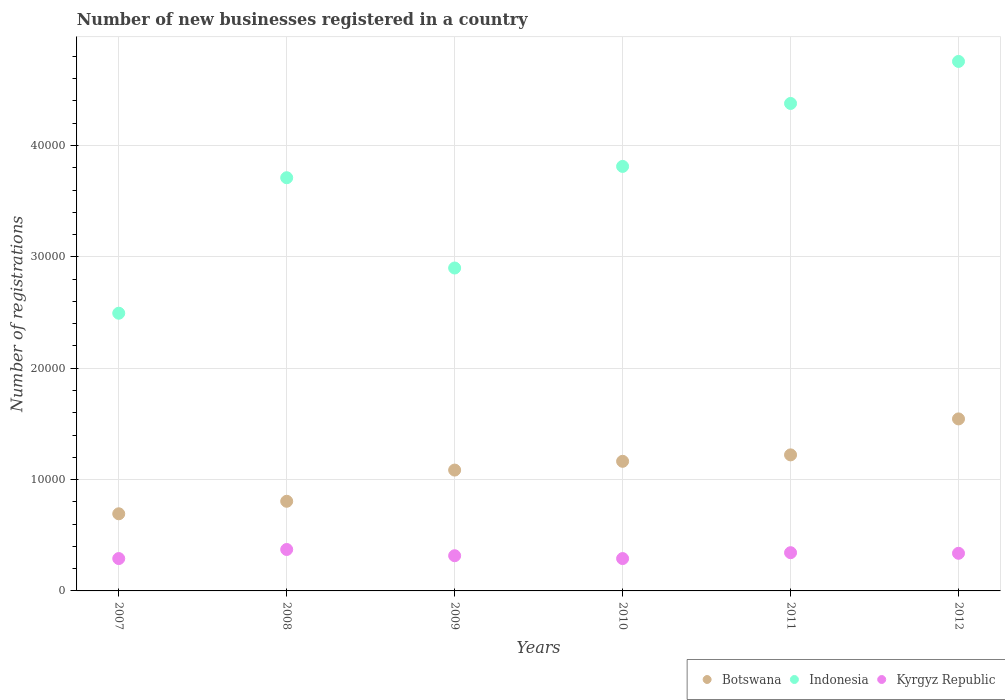What is the number of new businesses registered in Kyrgyz Republic in 2009?
Keep it short and to the point. 3161. Across all years, what is the maximum number of new businesses registered in Kyrgyz Republic?
Ensure brevity in your answer.  3721. Across all years, what is the minimum number of new businesses registered in Kyrgyz Republic?
Your response must be concise. 2905. In which year was the number of new businesses registered in Botswana minimum?
Keep it short and to the point. 2007. What is the total number of new businesses registered in Botswana in the graph?
Make the answer very short. 6.51e+04. What is the difference between the number of new businesses registered in Kyrgyz Republic in 2009 and that in 2012?
Provide a succinct answer. -218. What is the difference between the number of new businesses registered in Indonesia in 2012 and the number of new businesses registered in Botswana in 2010?
Keep it short and to the point. 3.59e+04. What is the average number of new businesses registered in Indonesia per year?
Offer a very short reply. 3.67e+04. In the year 2008, what is the difference between the number of new businesses registered in Kyrgyz Republic and number of new businesses registered in Botswana?
Your answer should be very brief. -4329. In how many years, is the number of new businesses registered in Botswana greater than 28000?
Your answer should be compact. 0. What is the ratio of the number of new businesses registered in Kyrgyz Republic in 2007 to that in 2009?
Provide a succinct answer. 0.92. Is the number of new businesses registered in Indonesia in 2010 less than that in 2012?
Ensure brevity in your answer.  Yes. Is the difference between the number of new businesses registered in Kyrgyz Republic in 2009 and 2012 greater than the difference between the number of new businesses registered in Botswana in 2009 and 2012?
Keep it short and to the point. Yes. What is the difference between the highest and the second highest number of new businesses registered in Kyrgyz Republic?
Ensure brevity in your answer.  288. What is the difference between the highest and the lowest number of new businesses registered in Botswana?
Your response must be concise. 8520. Is the sum of the number of new businesses registered in Indonesia in 2007 and 2009 greater than the maximum number of new businesses registered in Kyrgyz Republic across all years?
Your answer should be compact. Yes. Does the number of new businesses registered in Kyrgyz Republic monotonically increase over the years?
Give a very brief answer. No. What is the difference between two consecutive major ticks on the Y-axis?
Your answer should be very brief. 10000. Are the values on the major ticks of Y-axis written in scientific E-notation?
Offer a terse response. No. Does the graph contain any zero values?
Provide a short and direct response. No. Where does the legend appear in the graph?
Offer a terse response. Bottom right. What is the title of the graph?
Ensure brevity in your answer.  Number of new businesses registered in a country. What is the label or title of the Y-axis?
Provide a short and direct response. Number of registrations. What is the Number of registrations in Botswana in 2007?
Provide a short and direct response. 6927. What is the Number of registrations of Indonesia in 2007?
Your answer should be compact. 2.49e+04. What is the Number of registrations of Kyrgyz Republic in 2007?
Your response must be concise. 2906. What is the Number of registrations of Botswana in 2008?
Your answer should be very brief. 8050. What is the Number of registrations of Indonesia in 2008?
Make the answer very short. 3.71e+04. What is the Number of registrations of Kyrgyz Republic in 2008?
Your response must be concise. 3721. What is the Number of registrations of Botswana in 2009?
Ensure brevity in your answer.  1.09e+04. What is the Number of registrations of Indonesia in 2009?
Your response must be concise. 2.90e+04. What is the Number of registrations in Kyrgyz Republic in 2009?
Provide a short and direct response. 3161. What is the Number of registrations in Botswana in 2010?
Your response must be concise. 1.16e+04. What is the Number of registrations of Indonesia in 2010?
Your answer should be compact. 3.81e+04. What is the Number of registrations of Kyrgyz Republic in 2010?
Your answer should be compact. 2905. What is the Number of registrations of Botswana in 2011?
Ensure brevity in your answer.  1.22e+04. What is the Number of registrations in Indonesia in 2011?
Your answer should be very brief. 4.38e+04. What is the Number of registrations of Kyrgyz Republic in 2011?
Offer a terse response. 3433. What is the Number of registrations of Botswana in 2012?
Your response must be concise. 1.54e+04. What is the Number of registrations in Indonesia in 2012?
Offer a terse response. 4.75e+04. What is the Number of registrations of Kyrgyz Republic in 2012?
Provide a succinct answer. 3379. Across all years, what is the maximum Number of registrations in Botswana?
Your answer should be compact. 1.54e+04. Across all years, what is the maximum Number of registrations of Indonesia?
Offer a terse response. 4.75e+04. Across all years, what is the maximum Number of registrations in Kyrgyz Republic?
Give a very brief answer. 3721. Across all years, what is the minimum Number of registrations in Botswana?
Make the answer very short. 6927. Across all years, what is the minimum Number of registrations of Indonesia?
Provide a short and direct response. 2.49e+04. Across all years, what is the minimum Number of registrations of Kyrgyz Republic?
Ensure brevity in your answer.  2905. What is the total Number of registrations in Botswana in the graph?
Provide a short and direct response. 6.51e+04. What is the total Number of registrations in Indonesia in the graph?
Your answer should be compact. 2.20e+05. What is the total Number of registrations of Kyrgyz Republic in the graph?
Provide a short and direct response. 1.95e+04. What is the difference between the Number of registrations of Botswana in 2007 and that in 2008?
Give a very brief answer. -1123. What is the difference between the Number of registrations in Indonesia in 2007 and that in 2008?
Keep it short and to the point. -1.22e+04. What is the difference between the Number of registrations in Kyrgyz Republic in 2007 and that in 2008?
Offer a very short reply. -815. What is the difference between the Number of registrations in Botswana in 2007 and that in 2009?
Keep it short and to the point. -3925. What is the difference between the Number of registrations of Indonesia in 2007 and that in 2009?
Offer a terse response. -4060. What is the difference between the Number of registrations in Kyrgyz Republic in 2007 and that in 2009?
Ensure brevity in your answer.  -255. What is the difference between the Number of registrations in Botswana in 2007 and that in 2010?
Provide a succinct answer. -4712. What is the difference between the Number of registrations in Indonesia in 2007 and that in 2010?
Give a very brief answer. -1.32e+04. What is the difference between the Number of registrations of Kyrgyz Republic in 2007 and that in 2010?
Your answer should be very brief. 1. What is the difference between the Number of registrations in Botswana in 2007 and that in 2011?
Offer a very short reply. -5290. What is the difference between the Number of registrations in Indonesia in 2007 and that in 2011?
Keep it short and to the point. -1.88e+04. What is the difference between the Number of registrations in Kyrgyz Republic in 2007 and that in 2011?
Your answer should be very brief. -527. What is the difference between the Number of registrations in Botswana in 2007 and that in 2012?
Offer a very short reply. -8520. What is the difference between the Number of registrations in Indonesia in 2007 and that in 2012?
Offer a very short reply. -2.26e+04. What is the difference between the Number of registrations of Kyrgyz Republic in 2007 and that in 2012?
Your answer should be compact. -473. What is the difference between the Number of registrations in Botswana in 2008 and that in 2009?
Keep it short and to the point. -2802. What is the difference between the Number of registrations in Indonesia in 2008 and that in 2009?
Ensure brevity in your answer.  8108. What is the difference between the Number of registrations in Kyrgyz Republic in 2008 and that in 2009?
Provide a short and direct response. 560. What is the difference between the Number of registrations in Botswana in 2008 and that in 2010?
Give a very brief answer. -3589. What is the difference between the Number of registrations of Indonesia in 2008 and that in 2010?
Offer a terse response. -1016. What is the difference between the Number of registrations in Kyrgyz Republic in 2008 and that in 2010?
Your answer should be compact. 816. What is the difference between the Number of registrations of Botswana in 2008 and that in 2011?
Give a very brief answer. -4167. What is the difference between the Number of registrations of Indonesia in 2008 and that in 2011?
Your answer should be very brief. -6669. What is the difference between the Number of registrations in Kyrgyz Republic in 2008 and that in 2011?
Provide a short and direct response. 288. What is the difference between the Number of registrations of Botswana in 2008 and that in 2012?
Ensure brevity in your answer.  -7397. What is the difference between the Number of registrations of Indonesia in 2008 and that in 2012?
Offer a terse response. -1.04e+04. What is the difference between the Number of registrations in Kyrgyz Republic in 2008 and that in 2012?
Offer a terse response. 342. What is the difference between the Number of registrations of Botswana in 2009 and that in 2010?
Make the answer very short. -787. What is the difference between the Number of registrations of Indonesia in 2009 and that in 2010?
Your response must be concise. -9124. What is the difference between the Number of registrations of Kyrgyz Republic in 2009 and that in 2010?
Offer a terse response. 256. What is the difference between the Number of registrations in Botswana in 2009 and that in 2011?
Keep it short and to the point. -1365. What is the difference between the Number of registrations of Indonesia in 2009 and that in 2011?
Offer a terse response. -1.48e+04. What is the difference between the Number of registrations of Kyrgyz Republic in 2009 and that in 2011?
Your answer should be compact. -272. What is the difference between the Number of registrations in Botswana in 2009 and that in 2012?
Make the answer very short. -4595. What is the difference between the Number of registrations in Indonesia in 2009 and that in 2012?
Ensure brevity in your answer.  -1.86e+04. What is the difference between the Number of registrations of Kyrgyz Republic in 2009 and that in 2012?
Your answer should be compact. -218. What is the difference between the Number of registrations of Botswana in 2010 and that in 2011?
Your answer should be compact. -578. What is the difference between the Number of registrations of Indonesia in 2010 and that in 2011?
Your response must be concise. -5653. What is the difference between the Number of registrations of Kyrgyz Republic in 2010 and that in 2011?
Ensure brevity in your answer.  -528. What is the difference between the Number of registrations of Botswana in 2010 and that in 2012?
Give a very brief answer. -3808. What is the difference between the Number of registrations of Indonesia in 2010 and that in 2012?
Your response must be concise. -9427. What is the difference between the Number of registrations in Kyrgyz Republic in 2010 and that in 2012?
Your answer should be compact. -474. What is the difference between the Number of registrations of Botswana in 2011 and that in 2012?
Provide a succinct answer. -3230. What is the difference between the Number of registrations of Indonesia in 2011 and that in 2012?
Provide a succinct answer. -3774. What is the difference between the Number of registrations in Botswana in 2007 and the Number of registrations in Indonesia in 2008?
Make the answer very short. -3.02e+04. What is the difference between the Number of registrations of Botswana in 2007 and the Number of registrations of Kyrgyz Republic in 2008?
Your answer should be compact. 3206. What is the difference between the Number of registrations in Indonesia in 2007 and the Number of registrations in Kyrgyz Republic in 2008?
Offer a terse response. 2.12e+04. What is the difference between the Number of registrations of Botswana in 2007 and the Number of registrations of Indonesia in 2009?
Provide a succinct answer. -2.21e+04. What is the difference between the Number of registrations of Botswana in 2007 and the Number of registrations of Kyrgyz Republic in 2009?
Keep it short and to the point. 3766. What is the difference between the Number of registrations in Indonesia in 2007 and the Number of registrations in Kyrgyz Republic in 2009?
Offer a very short reply. 2.18e+04. What is the difference between the Number of registrations in Botswana in 2007 and the Number of registrations in Indonesia in 2010?
Your answer should be very brief. -3.12e+04. What is the difference between the Number of registrations in Botswana in 2007 and the Number of registrations in Kyrgyz Republic in 2010?
Keep it short and to the point. 4022. What is the difference between the Number of registrations in Indonesia in 2007 and the Number of registrations in Kyrgyz Republic in 2010?
Offer a terse response. 2.20e+04. What is the difference between the Number of registrations in Botswana in 2007 and the Number of registrations in Indonesia in 2011?
Ensure brevity in your answer.  -3.68e+04. What is the difference between the Number of registrations in Botswana in 2007 and the Number of registrations in Kyrgyz Republic in 2011?
Ensure brevity in your answer.  3494. What is the difference between the Number of registrations in Indonesia in 2007 and the Number of registrations in Kyrgyz Republic in 2011?
Your answer should be compact. 2.15e+04. What is the difference between the Number of registrations in Botswana in 2007 and the Number of registrations in Indonesia in 2012?
Offer a very short reply. -4.06e+04. What is the difference between the Number of registrations of Botswana in 2007 and the Number of registrations of Kyrgyz Republic in 2012?
Offer a terse response. 3548. What is the difference between the Number of registrations in Indonesia in 2007 and the Number of registrations in Kyrgyz Republic in 2012?
Provide a succinct answer. 2.16e+04. What is the difference between the Number of registrations of Botswana in 2008 and the Number of registrations of Indonesia in 2009?
Offer a very short reply. -2.09e+04. What is the difference between the Number of registrations in Botswana in 2008 and the Number of registrations in Kyrgyz Republic in 2009?
Provide a short and direct response. 4889. What is the difference between the Number of registrations of Indonesia in 2008 and the Number of registrations of Kyrgyz Republic in 2009?
Your answer should be compact. 3.39e+04. What is the difference between the Number of registrations of Botswana in 2008 and the Number of registrations of Indonesia in 2010?
Provide a succinct answer. -3.01e+04. What is the difference between the Number of registrations in Botswana in 2008 and the Number of registrations in Kyrgyz Republic in 2010?
Offer a terse response. 5145. What is the difference between the Number of registrations of Indonesia in 2008 and the Number of registrations of Kyrgyz Republic in 2010?
Give a very brief answer. 3.42e+04. What is the difference between the Number of registrations of Botswana in 2008 and the Number of registrations of Indonesia in 2011?
Offer a terse response. -3.57e+04. What is the difference between the Number of registrations of Botswana in 2008 and the Number of registrations of Kyrgyz Republic in 2011?
Give a very brief answer. 4617. What is the difference between the Number of registrations in Indonesia in 2008 and the Number of registrations in Kyrgyz Republic in 2011?
Ensure brevity in your answer.  3.37e+04. What is the difference between the Number of registrations of Botswana in 2008 and the Number of registrations of Indonesia in 2012?
Offer a terse response. -3.95e+04. What is the difference between the Number of registrations in Botswana in 2008 and the Number of registrations in Kyrgyz Republic in 2012?
Your answer should be very brief. 4671. What is the difference between the Number of registrations of Indonesia in 2008 and the Number of registrations of Kyrgyz Republic in 2012?
Offer a terse response. 3.37e+04. What is the difference between the Number of registrations of Botswana in 2009 and the Number of registrations of Indonesia in 2010?
Give a very brief answer. -2.73e+04. What is the difference between the Number of registrations of Botswana in 2009 and the Number of registrations of Kyrgyz Republic in 2010?
Your answer should be very brief. 7947. What is the difference between the Number of registrations of Indonesia in 2009 and the Number of registrations of Kyrgyz Republic in 2010?
Your answer should be compact. 2.61e+04. What is the difference between the Number of registrations in Botswana in 2009 and the Number of registrations in Indonesia in 2011?
Provide a short and direct response. -3.29e+04. What is the difference between the Number of registrations of Botswana in 2009 and the Number of registrations of Kyrgyz Republic in 2011?
Your answer should be very brief. 7419. What is the difference between the Number of registrations of Indonesia in 2009 and the Number of registrations of Kyrgyz Republic in 2011?
Your answer should be very brief. 2.56e+04. What is the difference between the Number of registrations of Botswana in 2009 and the Number of registrations of Indonesia in 2012?
Your answer should be compact. -3.67e+04. What is the difference between the Number of registrations of Botswana in 2009 and the Number of registrations of Kyrgyz Republic in 2012?
Keep it short and to the point. 7473. What is the difference between the Number of registrations in Indonesia in 2009 and the Number of registrations in Kyrgyz Republic in 2012?
Ensure brevity in your answer.  2.56e+04. What is the difference between the Number of registrations of Botswana in 2010 and the Number of registrations of Indonesia in 2011?
Your answer should be very brief. -3.21e+04. What is the difference between the Number of registrations in Botswana in 2010 and the Number of registrations in Kyrgyz Republic in 2011?
Ensure brevity in your answer.  8206. What is the difference between the Number of registrations of Indonesia in 2010 and the Number of registrations of Kyrgyz Republic in 2011?
Provide a succinct answer. 3.47e+04. What is the difference between the Number of registrations in Botswana in 2010 and the Number of registrations in Indonesia in 2012?
Your answer should be compact. -3.59e+04. What is the difference between the Number of registrations in Botswana in 2010 and the Number of registrations in Kyrgyz Republic in 2012?
Offer a terse response. 8260. What is the difference between the Number of registrations in Indonesia in 2010 and the Number of registrations in Kyrgyz Republic in 2012?
Offer a very short reply. 3.47e+04. What is the difference between the Number of registrations of Botswana in 2011 and the Number of registrations of Indonesia in 2012?
Your answer should be compact. -3.53e+04. What is the difference between the Number of registrations in Botswana in 2011 and the Number of registrations in Kyrgyz Republic in 2012?
Offer a terse response. 8838. What is the difference between the Number of registrations of Indonesia in 2011 and the Number of registrations of Kyrgyz Republic in 2012?
Your answer should be compact. 4.04e+04. What is the average Number of registrations of Botswana per year?
Keep it short and to the point. 1.09e+04. What is the average Number of registrations of Indonesia per year?
Your answer should be very brief. 3.67e+04. What is the average Number of registrations of Kyrgyz Republic per year?
Offer a terse response. 3250.83. In the year 2007, what is the difference between the Number of registrations of Botswana and Number of registrations of Indonesia?
Provide a succinct answer. -1.80e+04. In the year 2007, what is the difference between the Number of registrations of Botswana and Number of registrations of Kyrgyz Republic?
Give a very brief answer. 4021. In the year 2007, what is the difference between the Number of registrations of Indonesia and Number of registrations of Kyrgyz Republic?
Your answer should be very brief. 2.20e+04. In the year 2008, what is the difference between the Number of registrations in Botswana and Number of registrations in Indonesia?
Your response must be concise. -2.91e+04. In the year 2008, what is the difference between the Number of registrations of Botswana and Number of registrations of Kyrgyz Republic?
Your response must be concise. 4329. In the year 2008, what is the difference between the Number of registrations of Indonesia and Number of registrations of Kyrgyz Republic?
Provide a succinct answer. 3.34e+04. In the year 2009, what is the difference between the Number of registrations in Botswana and Number of registrations in Indonesia?
Give a very brief answer. -1.81e+04. In the year 2009, what is the difference between the Number of registrations in Botswana and Number of registrations in Kyrgyz Republic?
Your answer should be very brief. 7691. In the year 2009, what is the difference between the Number of registrations in Indonesia and Number of registrations in Kyrgyz Republic?
Keep it short and to the point. 2.58e+04. In the year 2010, what is the difference between the Number of registrations of Botswana and Number of registrations of Indonesia?
Offer a terse response. -2.65e+04. In the year 2010, what is the difference between the Number of registrations of Botswana and Number of registrations of Kyrgyz Republic?
Keep it short and to the point. 8734. In the year 2010, what is the difference between the Number of registrations of Indonesia and Number of registrations of Kyrgyz Republic?
Keep it short and to the point. 3.52e+04. In the year 2011, what is the difference between the Number of registrations in Botswana and Number of registrations in Indonesia?
Your response must be concise. -3.16e+04. In the year 2011, what is the difference between the Number of registrations in Botswana and Number of registrations in Kyrgyz Republic?
Your answer should be compact. 8784. In the year 2011, what is the difference between the Number of registrations of Indonesia and Number of registrations of Kyrgyz Republic?
Your answer should be compact. 4.03e+04. In the year 2012, what is the difference between the Number of registrations in Botswana and Number of registrations in Indonesia?
Give a very brief answer. -3.21e+04. In the year 2012, what is the difference between the Number of registrations of Botswana and Number of registrations of Kyrgyz Republic?
Ensure brevity in your answer.  1.21e+04. In the year 2012, what is the difference between the Number of registrations in Indonesia and Number of registrations in Kyrgyz Republic?
Offer a very short reply. 4.42e+04. What is the ratio of the Number of registrations of Botswana in 2007 to that in 2008?
Offer a terse response. 0.86. What is the ratio of the Number of registrations of Indonesia in 2007 to that in 2008?
Make the answer very short. 0.67. What is the ratio of the Number of registrations of Kyrgyz Republic in 2007 to that in 2008?
Provide a succinct answer. 0.78. What is the ratio of the Number of registrations in Botswana in 2007 to that in 2009?
Ensure brevity in your answer.  0.64. What is the ratio of the Number of registrations in Indonesia in 2007 to that in 2009?
Ensure brevity in your answer.  0.86. What is the ratio of the Number of registrations in Kyrgyz Republic in 2007 to that in 2009?
Give a very brief answer. 0.92. What is the ratio of the Number of registrations in Botswana in 2007 to that in 2010?
Your response must be concise. 0.6. What is the ratio of the Number of registrations in Indonesia in 2007 to that in 2010?
Offer a very short reply. 0.65. What is the ratio of the Number of registrations in Botswana in 2007 to that in 2011?
Your response must be concise. 0.57. What is the ratio of the Number of registrations of Indonesia in 2007 to that in 2011?
Offer a very short reply. 0.57. What is the ratio of the Number of registrations of Kyrgyz Republic in 2007 to that in 2011?
Give a very brief answer. 0.85. What is the ratio of the Number of registrations of Botswana in 2007 to that in 2012?
Your response must be concise. 0.45. What is the ratio of the Number of registrations of Indonesia in 2007 to that in 2012?
Make the answer very short. 0.52. What is the ratio of the Number of registrations of Kyrgyz Republic in 2007 to that in 2012?
Your answer should be very brief. 0.86. What is the ratio of the Number of registrations of Botswana in 2008 to that in 2009?
Your response must be concise. 0.74. What is the ratio of the Number of registrations in Indonesia in 2008 to that in 2009?
Provide a short and direct response. 1.28. What is the ratio of the Number of registrations in Kyrgyz Republic in 2008 to that in 2009?
Ensure brevity in your answer.  1.18. What is the ratio of the Number of registrations in Botswana in 2008 to that in 2010?
Your answer should be very brief. 0.69. What is the ratio of the Number of registrations of Indonesia in 2008 to that in 2010?
Offer a very short reply. 0.97. What is the ratio of the Number of registrations in Kyrgyz Republic in 2008 to that in 2010?
Ensure brevity in your answer.  1.28. What is the ratio of the Number of registrations in Botswana in 2008 to that in 2011?
Your answer should be compact. 0.66. What is the ratio of the Number of registrations of Indonesia in 2008 to that in 2011?
Your response must be concise. 0.85. What is the ratio of the Number of registrations in Kyrgyz Republic in 2008 to that in 2011?
Provide a short and direct response. 1.08. What is the ratio of the Number of registrations in Botswana in 2008 to that in 2012?
Your answer should be compact. 0.52. What is the ratio of the Number of registrations of Indonesia in 2008 to that in 2012?
Provide a succinct answer. 0.78. What is the ratio of the Number of registrations in Kyrgyz Republic in 2008 to that in 2012?
Your answer should be compact. 1.1. What is the ratio of the Number of registrations of Botswana in 2009 to that in 2010?
Give a very brief answer. 0.93. What is the ratio of the Number of registrations in Indonesia in 2009 to that in 2010?
Offer a very short reply. 0.76. What is the ratio of the Number of registrations of Kyrgyz Republic in 2009 to that in 2010?
Your response must be concise. 1.09. What is the ratio of the Number of registrations in Botswana in 2009 to that in 2011?
Your response must be concise. 0.89. What is the ratio of the Number of registrations of Indonesia in 2009 to that in 2011?
Make the answer very short. 0.66. What is the ratio of the Number of registrations in Kyrgyz Republic in 2009 to that in 2011?
Your answer should be very brief. 0.92. What is the ratio of the Number of registrations of Botswana in 2009 to that in 2012?
Give a very brief answer. 0.7. What is the ratio of the Number of registrations of Indonesia in 2009 to that in 2012?
Provide a short and direct response. 0.61. What is the ratio of the Number of registrations of Kyrgyz Republic in 2009 to that in 2012?
Ensure brevity in your answer.  0.94. What is the ratio of the Number of registrations of Botswana in 2010 to that in 2011?
Offer a terse response. 0.95. What is the ratio of the Number of registrations in Indonesia in 2010 to that in 2011?
Offer a very short reply. 0.87. What is the ratio of the Number of registrations in Kyrgyz Republic in 2010 to that in 2011?
Provide a succinct answer. 0.85. What is the ratio of the Number of registrations of Botswana in 2010 to that in 2012?
Your answer should be compact. 0.75. What is the ratio of the Number of registrations in Indonesia in 2010 to that in 2012?
Make the answer very short. 0.8. What is the ratio of the Number of registrations of Kyrgyz Republic in 2010 to that in 2012?
Provide a succinct answer. 0.86. What is the ratio of the Number of registrations of Botswana in 2011 to that in 2012?
Your answer should be very brief. 0.79. What is the ratio of the Number of registrations of Indonesia in 2011 to that in 2012?
Your answer should be very brief. 0.92. What is the ratio of the Number of registrations in Kyrgyz Republic in 2011 to that in 2012?
Offer a terse response. 1.02. What is the difference between the highest and the second highest Number of registrations of Botswana?
Provide a short and direct response. 3230. What is the difference between the highest and the second highest Number of registrations of Indonesia?
Offer a terse response. 3774. What is the difference between the highest and the second highest Number of registrations in Kyrgyz Republic?
Offer a very short reply. 288. What is the difference between the highest and the lowest Number of registrations of Botswana?
Offer a terse response. 8520. What is the difference between the highest and the lowest Number of registrations of Indonesia?
Provide a succinct answer. 2.26e+04. What is the difference between the highest and the lowest Number of registrations in Kyrgyz Republic?
Keep it short and to the point. 816. 